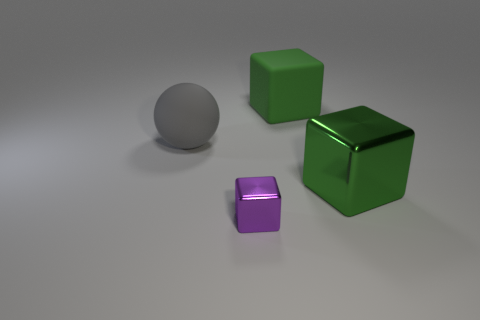There is a thing that is the same color as the big shiny cube; what material is it?
Your response must be concise. Rubber. There is a purple cube; what number of large green objects are in front of it?
Provide a short and direct response. 0. Are there the same number of gray things that are in front of the gray ball and tiny brown rubber things?
Keep it short and to the point. Yes. Are the big gray sphere and the tiny purple object made of the same material?
Provide a short and direct response. No. What is the size of the thing that is in front of the large green matte thing and on the right side of the purple metallic cube?
Your answer should be compact. Large. How many purple metallic objects have the same size as the purple cube?
Ensure brevity in your answer.  0. There is a gray ball on the left side of the metal object behind the purple metallic cube; how big is it?
Ensure brevity in your answer.  Large. There is a thing behind the ball; is it the same shape as the green thing in front of the large gray object?
Ensure brevity in your answer.  Yes. There is a block that is left of the big green shiny thing and behind the small purple object; what is its color?
Keep it short and to the point. Green. Is there another large ball of the same color as the ball?
Make the answer very short. No. 